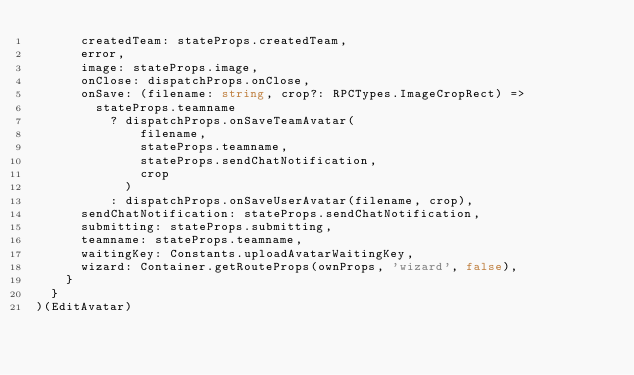Convert code to text. <code><loc_0><loc_0><loc_500><loc_500><_TypeScript_>      createdTeam: stateProps.createdTeam,
      error,
      image: stateProps.image,
      onClose: dispatchProps.onClose,
      onSave: (filename: string, crop?: RPCTypes.ImageCropRect) =>
        stateProps.teamname
          ? dispatchProps.onSaveTeamAvatar(
              filename,
              stateProps.teamname,
              stateProps.sendChatNotification,
              crop
            )
          : dispatchProps.onSaveUserAvatar(filename, crop),
      sendChatNotification: stateProps.sendChatNotification,
      submitting: stateProps.submitting,
      teamname: stateProps.teamname,
      waitingKey: Constants.uploadAvatarWaitingKey,
      wizard: Container.getRouteProps(ownProps, 'wizard', false),
    }
  }
)(EditAvatar)
</code> 